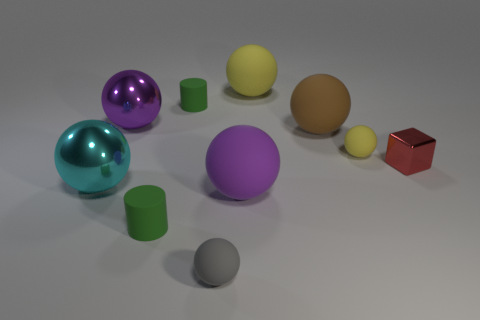Are there any other brown shiny balls that have the same size as the brown sphere?
Provide a short and direct response. No. There is a tiny sphere that is on the left side of the big yellow object; what is it made of?
Your answer should be compact. Rubber. Are there an equal number of tiny metallic things that are to the right of the large purple shiny sphere and big purple things left of the big purple matte ball?
Make the answer very short. Yes. There is a cylinder behind the purple matte ball; is it the same size as the metal object that is behind the red shiny cube?
Ensure brevity in your answer.  No. Is the number of metal things to the left of the small red thing greater than the number of large purple metal spheres?
Ensure brevity in your answer.  Yes. Does the gray thing have the same shape as the tiny red thing?
Make the answer very short. No. How many tiny cyan objects have the same material as the cube?
Provide a succinct answer. 0. What is the size of the gray rubber object that is the same shape as the tiny yellow matte thing?
Provide a succinct answer. Small. Do the cyan metal ball and the brown matte sphere have the same size?
Provide a short and direct response. Yes. There is a small green matte object that is right of the green matte cylinder that is in front of the small rubber cylinder that is behind the large cyan metal sphere; what shape is it?
Make the answer very short. Cylinder. 